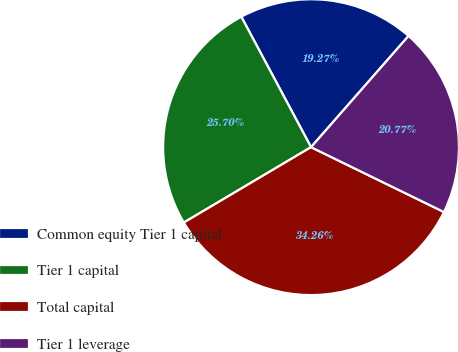Convert chart. <chart><loc_0><loc_0><loc_500><loc_500><pie_chart><fcel>Common equity Tier 1 capital<fcel>Tier 1 capital<fcel>Total capital<fcel>Tier 1 leverage<nl><fcel>19.27%<fcel>25.7%<fcel>34.26%<fcel>20.77%<nl></chart> 